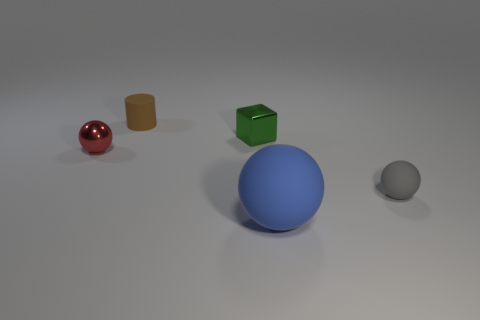Subtract all large matte balls. How many balls are left? 2 Subtract 1 spheres. How many spheres are left? 2 Add 3 large blue matte objects. How many objects exist? 8 Subtract all blocks. How many objects are left? 4 Subtract all big blue matte objects. Subtract all tiny metallic blocks. How many objects are left? 3 Add 5 big blue objects. How many big blue objects are left? 6 Add 3 small gray rubber things. How many small gray rubber things exist? 4 Subtract 0 red cubes. How many objects are left? 5 